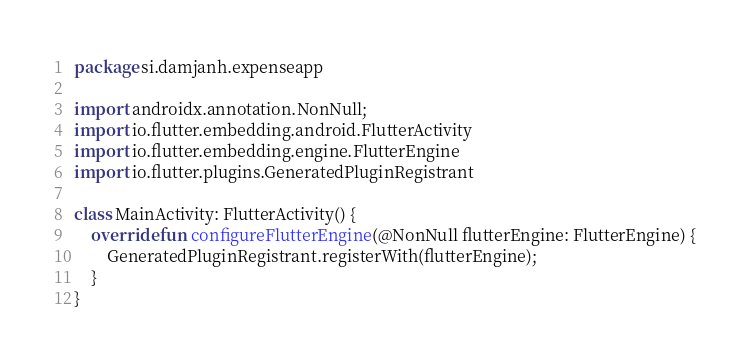<code> <loc_0><loc_0><loc_500><loc_500><_Kotlin_>package si.damjanh.expenseapp

import androidx.annotation.NonNull;
import io.flutter.embedding.android.FlutterActivity
import io.flutter.embedding.engine.FlutterEngine
import io.flutter.plugins.GeneratedPluginRegistrant

class MainActivity: FlutterActivity() {
    override fun configureFlutterEngine(@NonNull flutterEngine: FlutterEngine) {
        GeneratedPluginRegistrant.registerWith(flutterEngine);
    }
}
</code> 